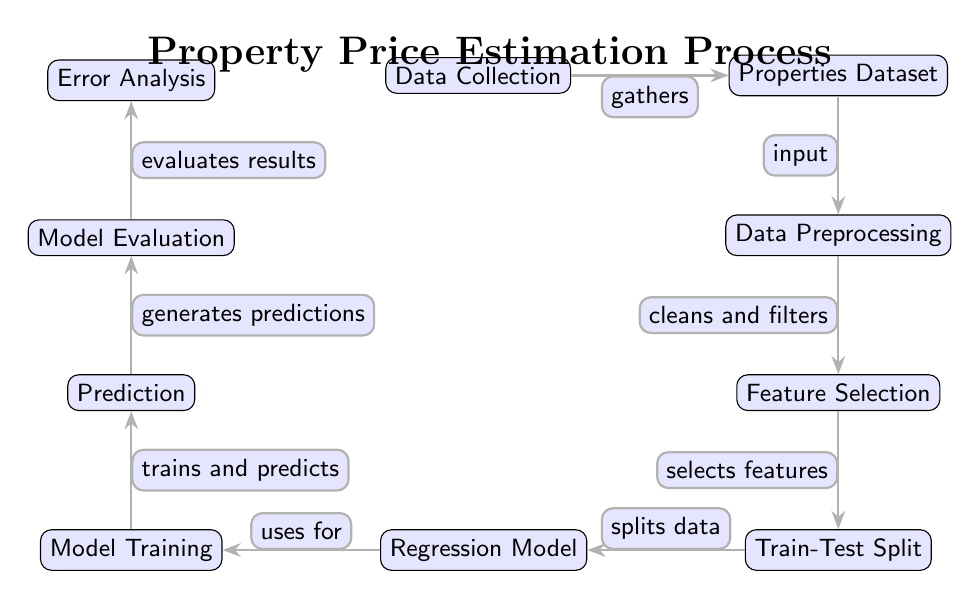What is the first step in the process? The first step is labeled "Data Collection," which is identified as the initial node in the diagram.
Answer: Data Collection How many nodes are in the diagram? By counting each of the labeled nodes vertically and horizontally within the diagram, there are a total of 10 nodes.
Answer: 10 What does the "Data Preprocessing" node do? The edge leading from "Properties Dataset" to "Data Preprocessing" indicates that this step "cleans and filters" the data.
Answer: Cleans and filters Which node comes after "Model Evaluation"? Following "Model Evaluation," the next node in the upward direction is "Error Analysis," as shown by the connecting edge.
Answer: Error Analysis How many edges are in the diagram? By visually counting the directed arrows that connect each pair of nodes, the diagram contains a total of 9 edges.
Answer: 9 What is the last step in the process? The last step is labeled "Error Analysis," which is the final node positioned above the "Model Evaluation" node.
Answer: Error Analysis Which node involves training the model? The "Model Training" node is designated for this task, connected by an edge that indicates it uses the regression model for training.
Answer: Model Training What is the function of the "Train-Test Split" node? The "Train-Test Split" node is associated with "splits data," which describes its role in dividing the dataset into training and testing subsets.
Answer: Splits data In what order do the nodes flow from "Data Collection" to "Model Evaluation"? The flow sequence is: Data Collection → Properties Dataset → Data Preprocessing → Feature Selection → Train-Test Split → Regression Model → Model Training → Prediction → Model Evaluation.
Answer: Data Collection → Properties Dataset → Data Preprocessing → Feature Selection → Train-Test Split → Regression Model → Model Training → Prediction → Model Evaluation 